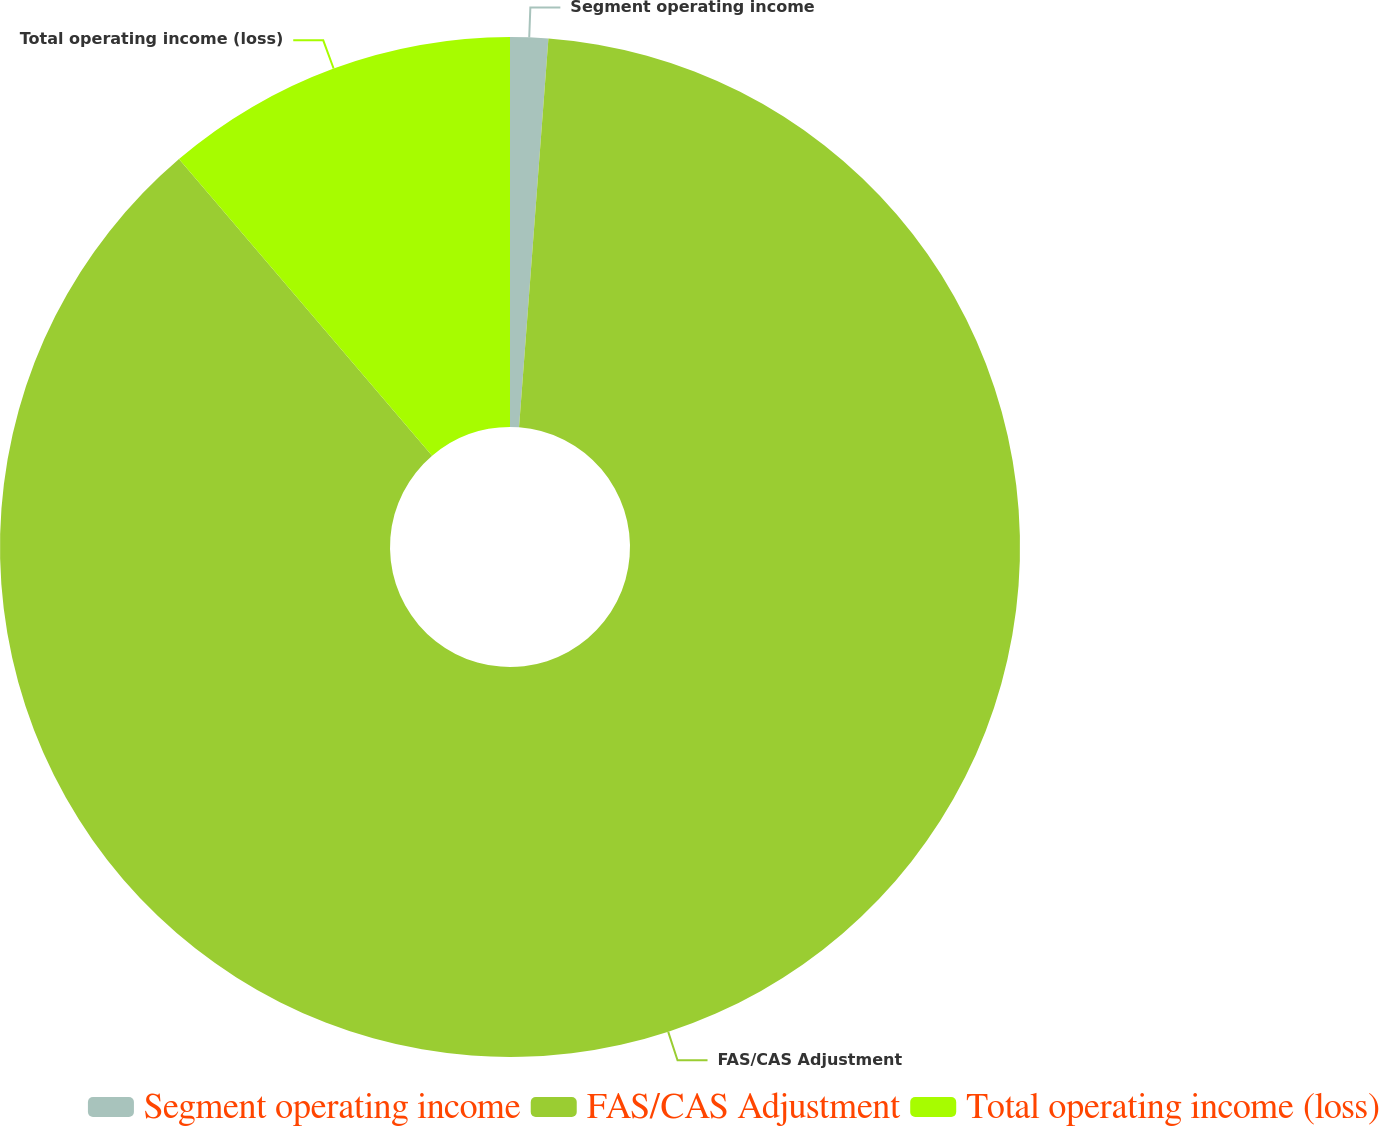Convert chart. <chart><loc_0><loc_0><loc_500><loc_500><pie_chart><fcel>Segment operating income<fcel>FAS/CAS Adjustment<fcel>Total operating income (loss)<nl><fcel>1.2%<fcel>87.55%<fcel>11.24%<nl></chart> 